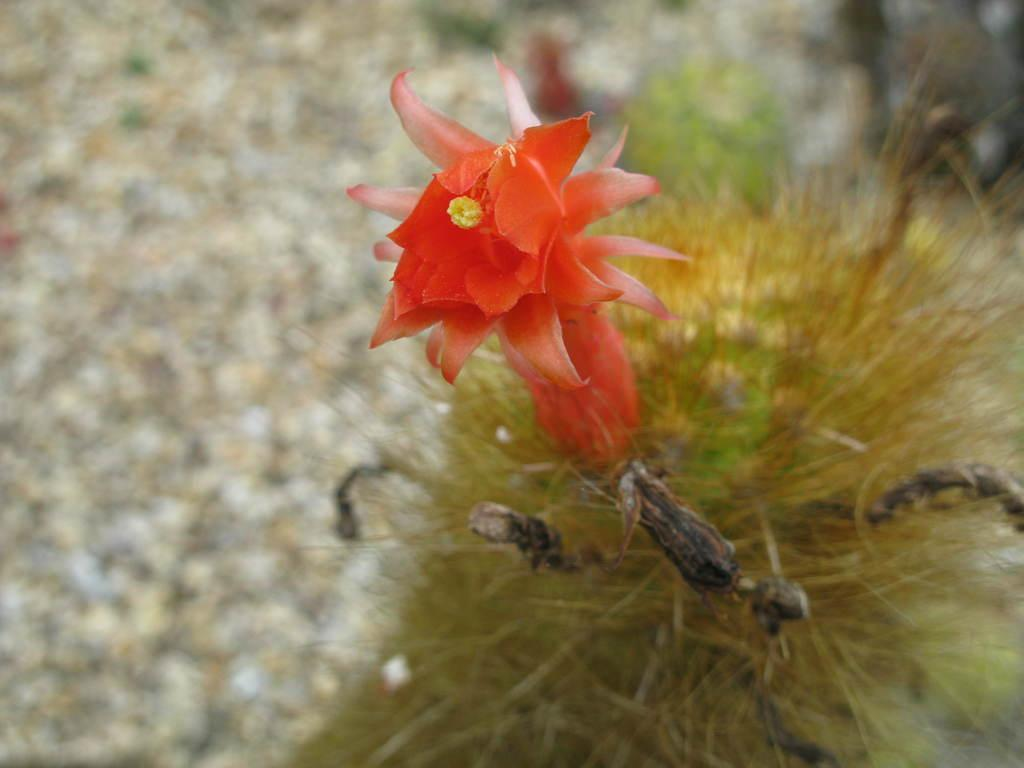What color is the flower on the plant in the image? The flower on the plant is red. What else can be seen in the image besides the flower? There are plants visible in the background. Can you describe the bottom of the image? The image might have stones at the bottom. How would you describe the clarity of the image? The image is blurry. What is the price of the seat in the image? There is no seat present in the image, so it is not possible to determine the price. 